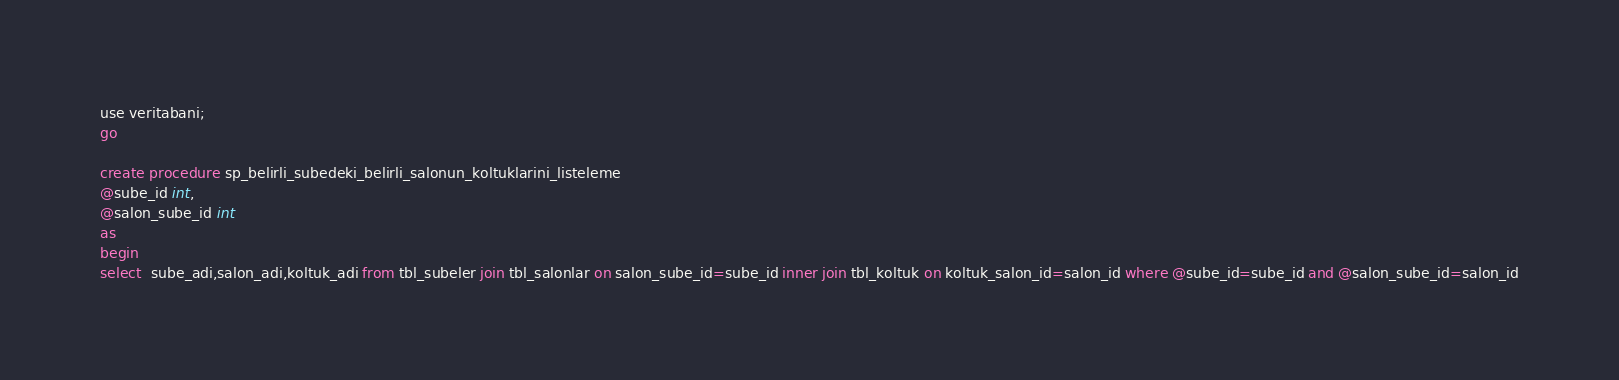<code> <loc_0><loc_0><loc_500><loc_500><_SQL_>use veritabani;
go

create procedure sp_belirli_subedeki_belirli_salonun_koltuklarini_listeleme
@sube_id int,
@salon_sube_id int
as
begin
select  sube_adi,salon_adi,koltuk_adi from tbl_subeler join tbl_salonlar on salon_sube_id=sube_id inner join tbl_koltuk on koltuk_salon_id=salon_id where @sube_id=sube_id and @salon_sube_id=salon_id</code> 